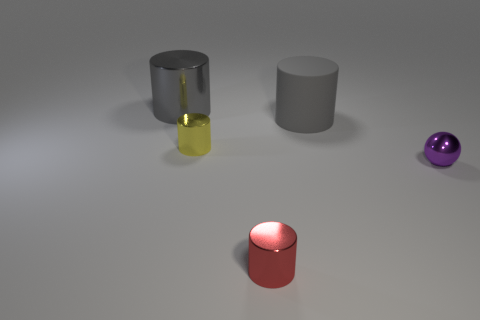How many red cylinders are on the right side of the purple shiny ball?
Your response must be concise. 0. How many objects are either small yellow shiny balls or gray objects?
Your answer should be compact. 2. How many red shiny cylinders have the same size as the rubber cylinder?
Make the answer very short. 0. There is a large rubber thing that is on the right side of the large cylinder behind the rubber object; what is its shape?
Make the answer very short. Cylinder. Is the number of purple metal things less than the number of metal objects?
Your answer should be compact. Yes. The thing that is on the right side of the big gray rubber cylinder is what color?
Offer a very short reply. Purple. There is a tiny object that is both on the left side of the small purple shiny sphere and on the right side of the yellow thing; what material is it made of?
Keep it short and to the point. Metal. The yellow thing that is made of the same material as the tiny purple object is what shape?
Your answer should be very brief. Cylinder. There is a red metallic cylinder that is on the left side of the sphere; what number of cylinders are to the right of it?
Your response must be concise. 1. What number of things are in front of the rubber cylinder and on the left side of the gray rubber cylinder?
Give a very brief answer. 2. 